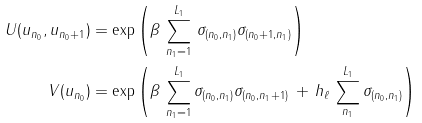<formula> <loc_0><loc_0><loc_500><loc_500>U ( u _ { n _ { 0 } } , u _ { n _ { 0 } + 1 } ) & = \exp \left ( \beta \, \sum _ { n _ { 1 } = 1 } ^ { L _ { 1 } } \, \sigma _ { ( n _ { 0 } , n _ { 1 } ) } \sigma _ { ( n _ { 0 } + 1 , n _ { 1 } ) } \right ) \\ V ( u _ { n _ { 0 } } ) & = \exp \left ( \beta \, \sum _ { n _ { 1 } = 1 } ^ { L _ { 1 } } \sigma _ { ( n _ { 0 } , n _ { 1 } ) } \sigma _ { ( n _ { 0 } , n _ { 1 } + 1 ) } \, + \, h _ { \ell } \, \sum _ { n _ { 1 } } ^ { L _ { 1 } } \sigma _ { ( n _ { 0 } , n _ { 1 } ) } \right ) \,</formula> 